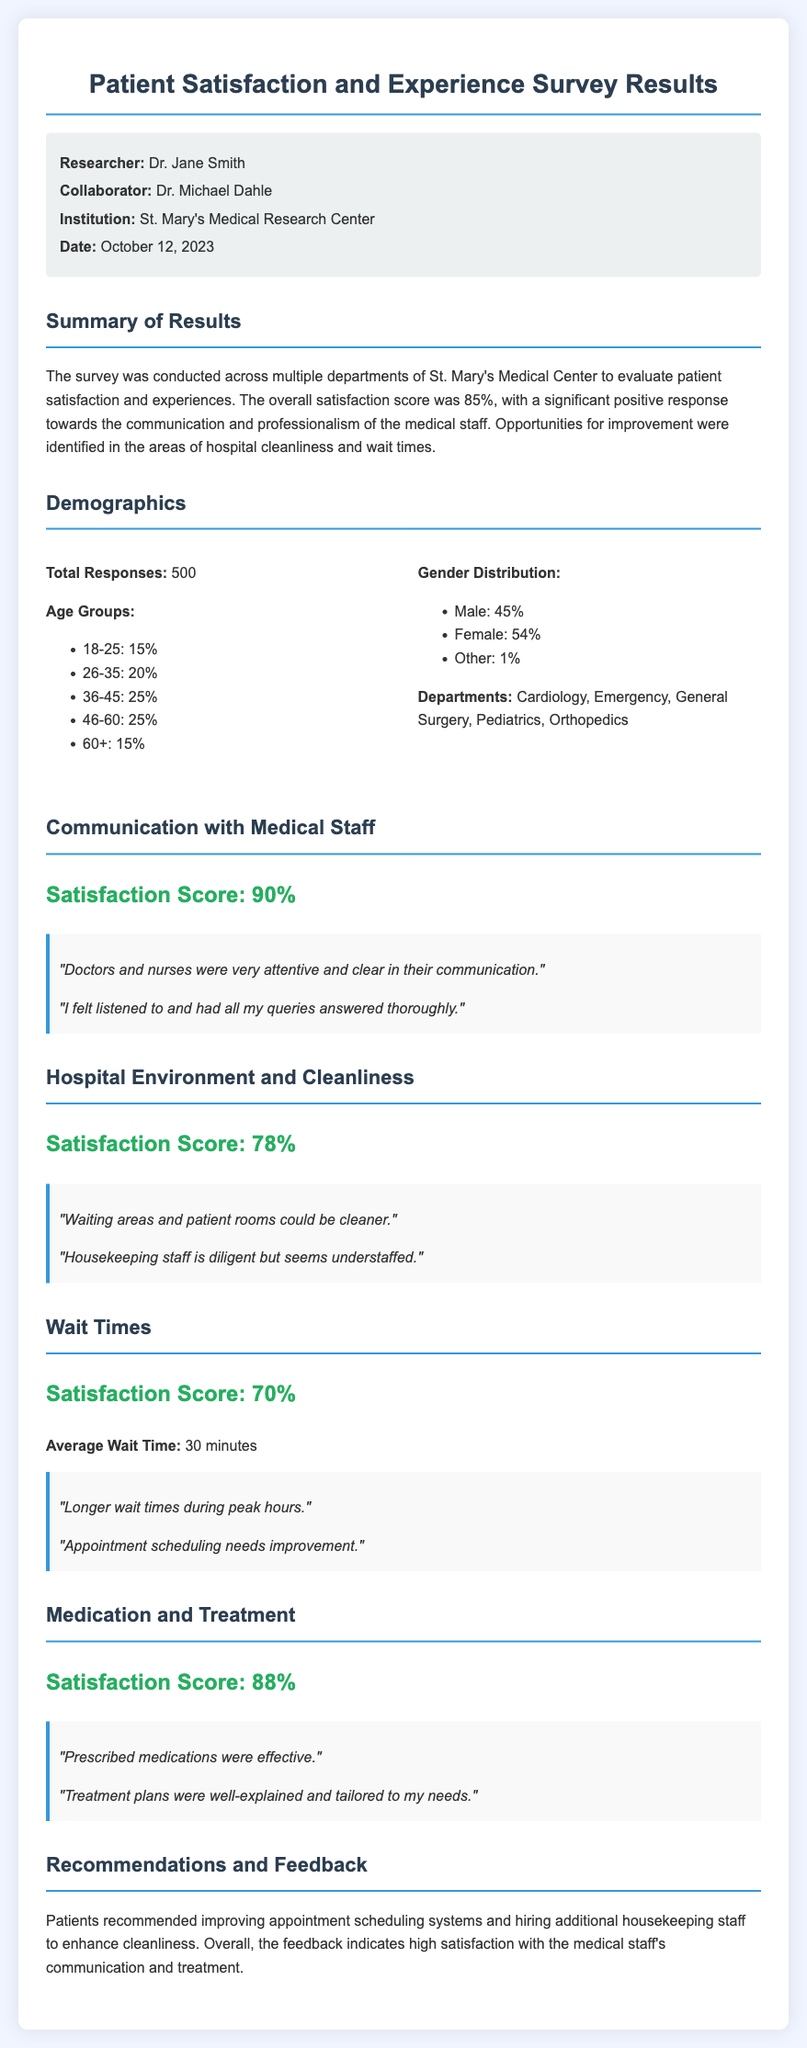What is the overall satisfaction score? The overall satisfaction score reported in the document is based on the survey results.
Answer: 85% Who conducted this survey? The document mentions that Dr. Jane Smith is the researcher who conducted the survey.
Answer: Dr. Jane Smith What is the satisfaction score for communication with medical staff? The satisfaction score specifically for this aspect of the survey is stated in the document.
Answer: 90% How many total responses were collected? The document specifies the total number of survey responses received.
Answer: 500 What percentage of respondents are aged 36-45? This information is provided in the demographics section of the document.
Answer: 25% What is one of the recommended areas for improvement mentioned in the document? The document includes recommendations based on patient feedback, highlighting areas needing improvement.
Answer: Appointment scheduling What is the average wait time reported in the survey? The document contains specific information on the average wait time experienced by patients.
Answer: 30 minutes What is the satisfaction score for hospital environment and cleanliness? The document presents the satisfaction score for this aspect, indicating patient feedback about cleanliness.
Answer: 78% What institution is associated with the survey? The document mentions the institution conducting the research.
Answer: St. Mary's Medical Research Center 